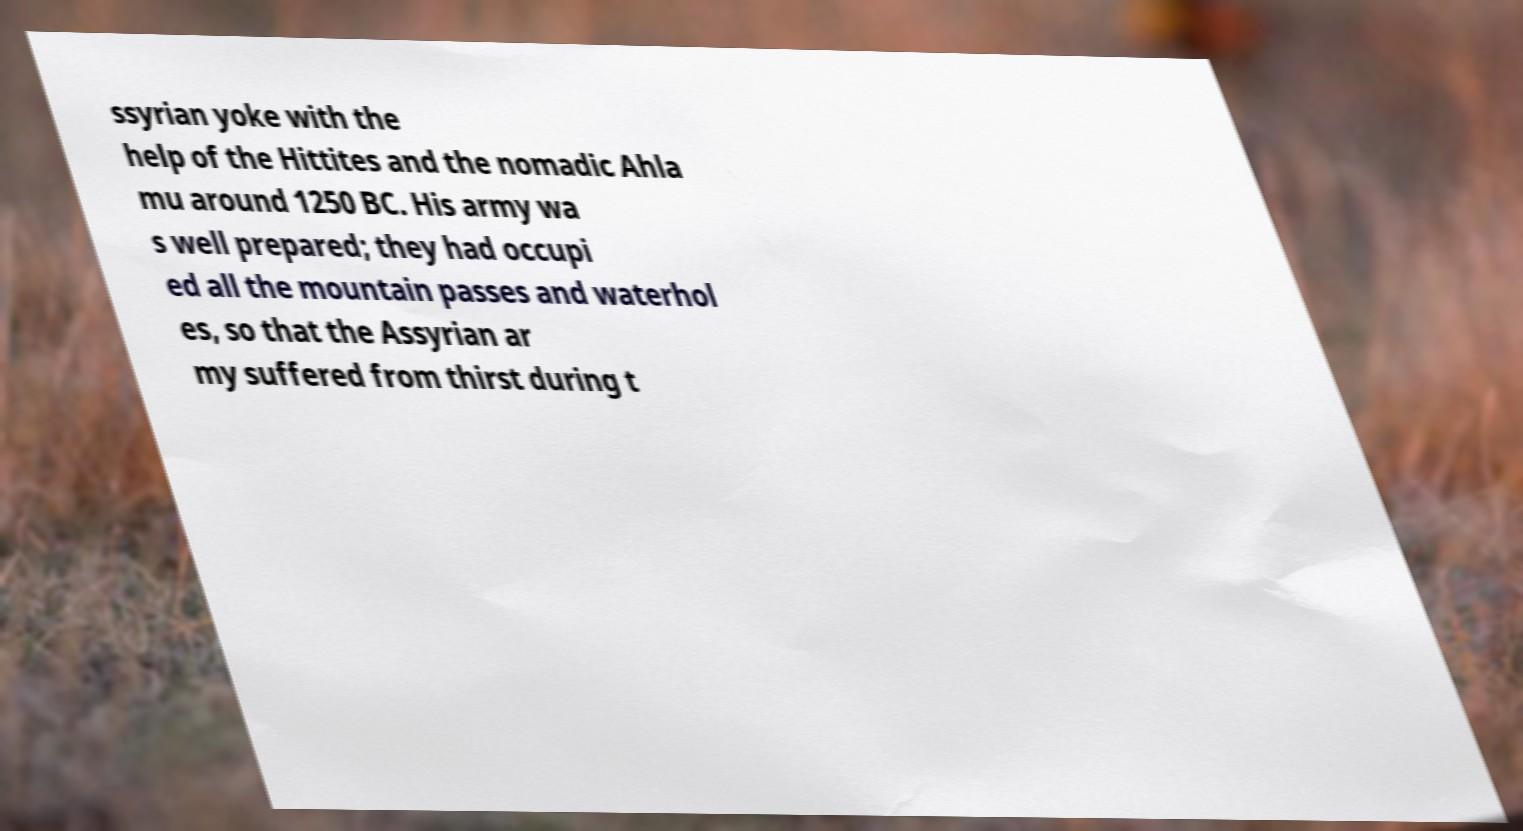Could you assist in decoding the text presented in this image and type it out clearly? ssyrian yoke with the help of the Hittites and the nomadic Ahla mu around 1250 BC. His army wa s well prepared; they had occupi ed all the mountain passes and waterhol es, so that the Assyrian ar my suffered from thirst during t 